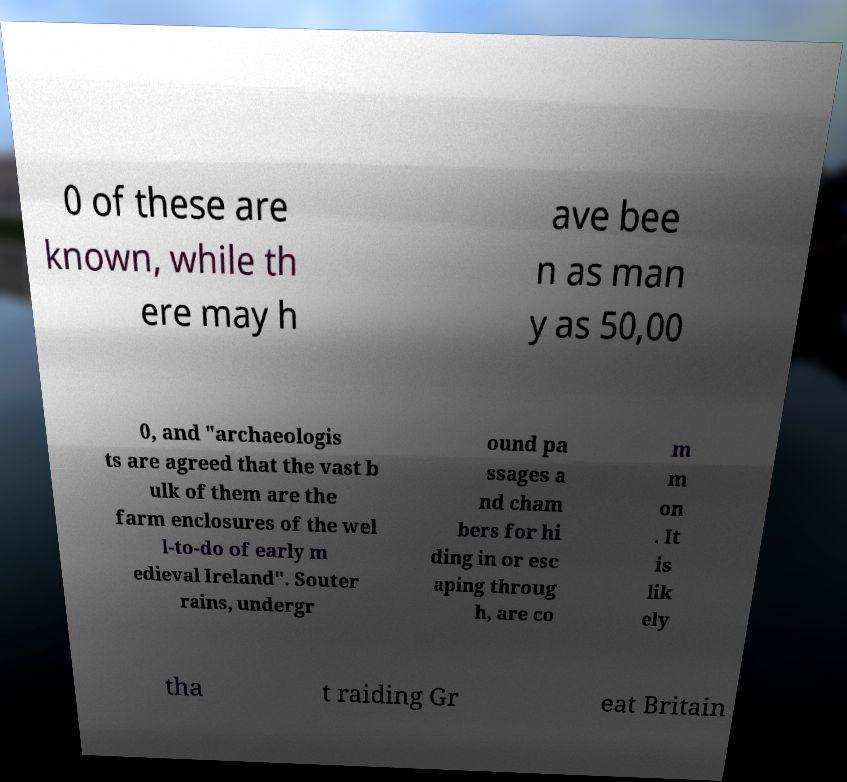Can you read and provide the text displayed in the image?This photo seems to have some interesting text. Can you extract and type it out for me? 0 of these are known, while th ere may h ave bee n as man y as 50,00 0, and "archaeologis ts are agreed that the vast b ulk of them are the farm enclosures of the wel l-to-do of early m edieval Ireland". Souter rains, undergr ound pa ssages a nd cham bers for hi ding in or esc aping throug h, are co m m on . It is lik ely tha t raiding Gr eat Britain 